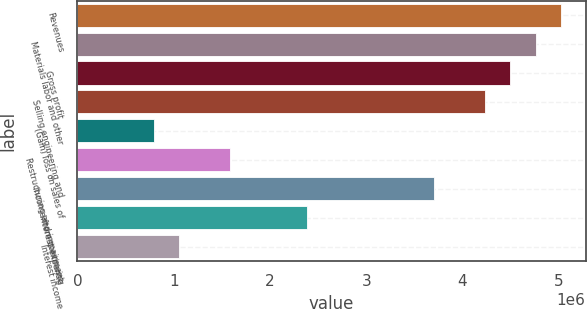<chart> <loc_0><loc_0><loc_500><loc_500><bar_chart><fcel>Revenues<fcel>Materials labor and other<fcel>Gross profit<fcel>Selling engineering and<fcel>(Gain) loss on sales of<fcel>Restructuring and impairment<fcel>Income from continuing<fcel>Interest expense<fcel>Interest income<nl><fcel>5.02882e+06<fcel>4.76415e+06<fcel>4.49948e+06<fcel>4.2348e+06<fcel>794039<fcel>1.58806e+06<fcel>3.70545e+06<fcel>2.38208e+06<fcel>1.05871e+06<nl></chart> 